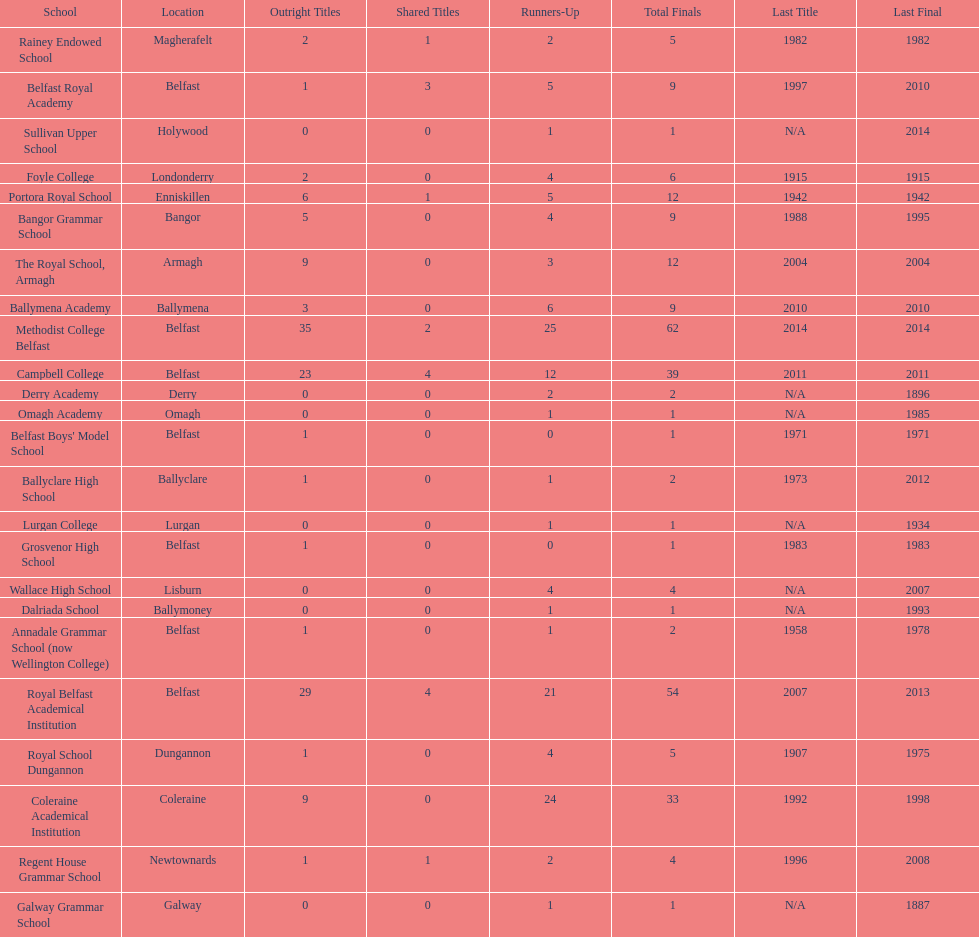How many schools had above 5 outright titles? 6. 